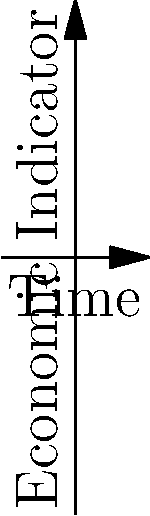Consider the cyclical nature of economic crises as illustrated in the graph above. If we represent this cycle as a cyclic subgroup of order 4 in group theory, with A, B, C, D, and E as elements, what is the generator of this subgroup? Express your answer in terms of these elements. To answer this question, let's follow these steps:

1) First, we need to understand what the graph represents. The blue curve shows the boom-bust cycle of the economy, while the red curve shows the underlying trend.

2) In group theory, a cyclic subgroup is a subgroup that can be generated by a single element of the group. This element is called the generator.

3) The question states that we have a cyclic subgroup of order 4. This means that applying the generator 4 times should bring us back to the starting point.

4) Looking at the graph, we can see that the cycle goes through 4 distinct points before returning to the start:
   A (start) → B (peak) → C (middle) → D (trough) → E (end, same as A)

5) In group theory notation, we can write this as:
   $e$ (identity) → $g$ → $g^2$ → $g^3$ → $g^4 = e$

6) The element that, when applied once, moves us from A to B, is the generator we're looking for.

7) In terms of the elements given, this movement from A to B can be represented as B itself, as it signifies the transformation from the starting point to the peak of the cycle.

Therefore, B is the generator of this cyclic subgroup.
Answer: B 